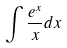Convert formula to latex. <formula><loc_0><loc_0><loc_500><loc_500>\int \frac { e ^ { x } } { x } d x</formula> 